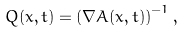<formula> <loc_0><loc_0><loc_500><loc_500>Q ( x , t ) = \left ( \nabla A ( x , t ) \right ) ^ { - 1 } ,</formula> 